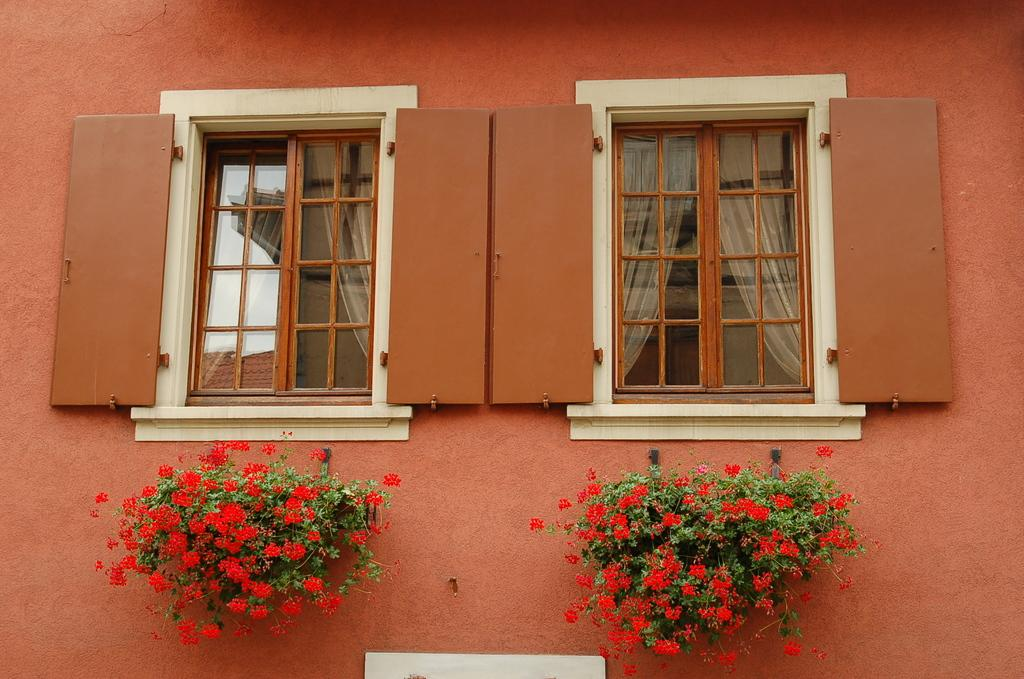What is present on the wall in the image? There is a wall with two windows in the image. What can be found near the windows? There are flower pots in the image. What can be seen through the windows? Curtains are visible through the windows. How many fingers can be seen holding the flower pots in the image? There are no fingers visible in the image, as it only shows a wall with two windows, flower pots, and curtains through the windows. 